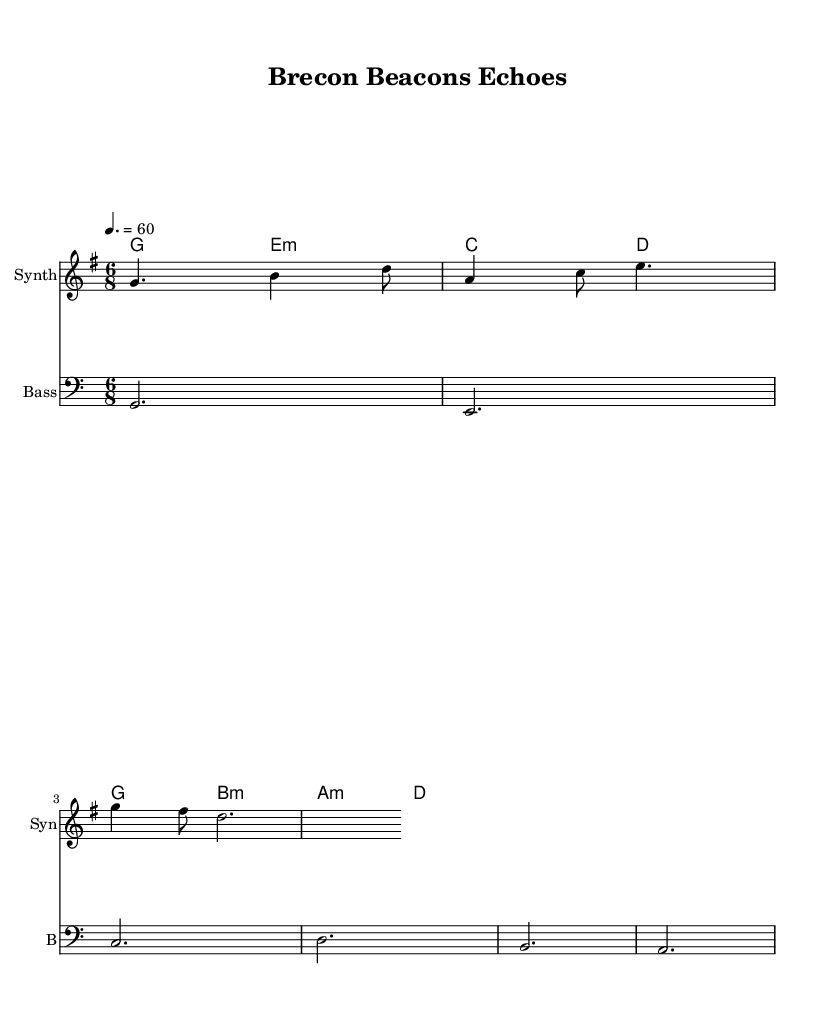What is the title of this piece? The title is indicated in the header of the sheet music, which states "Brecon Beacons Echoes."
Answer: Brecon Beacons Echoes What is the key signature of this music? The key signature is defined at the beginning of the score and shows one sharp, indicating it is G major.
Answer: G major What is the time signature of this music? The time signature is also given at the beginning alongside the key signature; it is notated as 6/8.
Answer: 6/8 What is the tempo marking for this piece? The tempo marking is located at the beginning of the sheet music and is set at a metronomic value of 60 beats per minute.
Answer: 60 How many measures are in the melody? To find the number of measures, we count the individual groupings of notes; the melody contains 3 measures.
Answer: 3 What instruments are indicated in the score? The score specifies the presence of two instruments: one for "Synth" and another for "Bass."
Answer: Synth, Bass Which chord follows G major in the harmonies? The harmonies are listed sequentially; immediately following G major is E minor.
Answer: E minor 